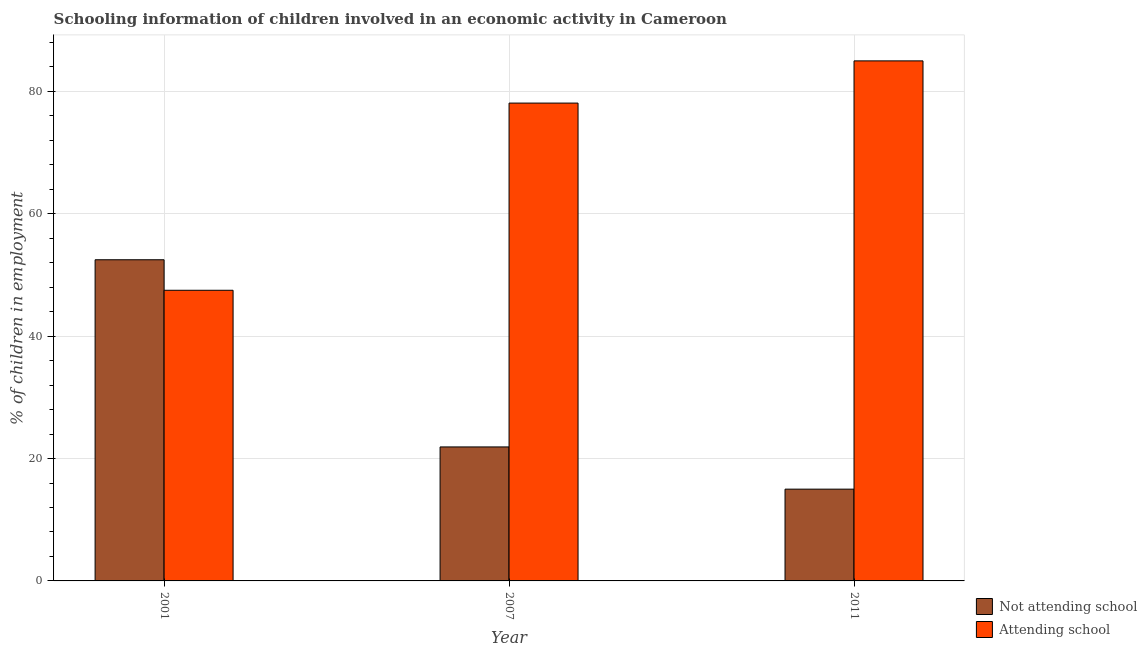How many different coloured bars are there?
Your answer should be very brief. 2. Are the number of bars on each tick of the X-axis equal?
Provide a short and direct response. Yes. How many bars are there on the 3rd tick from the right?
Keep it short and to the point. 2. What is the label of the 1st group of bars from the left?
Make the answer very short. 2001. In how many cases, is the number of bars for a given year not equal to the number of legend labels?
Offer a very short reply. 0. What is the percentage of employed children who are attending school in 2007?
Your response must be concise. 78.1. Across all years, what is the maximum percentage of employed children who are not attending school?
Ensure brevity in your answer.  52.49. Across all years, what is the minimum percentage of employed children who are not attending school?
Ensure brevity in your answer.  15. In which year was the percentage of employed children who are not attending school maximum?
Your answer should be compact. 2001. What is the total percentage of employed children who are not attending school in the graph?
Offer a terse response. 89.39. What is the difference between the percentage of employed children who are not attending school in 2007 and that in 2011?
Your answer should be compact. 6.9. What is the difference between the percentage of employed children who are attending school in 2001 and the percentage of employed children who are not attending school in 2007?
Your answer should be very brief. -30.59. What is the average percentage of employed children who are attending school per year?
Your answer should be compact. 70.2. In the year 2001, what is the difference between the percentage of employed children who are not attending school and percentage of employed children who are attending school?
Your answer should be compact. 0. What is the ratio of the percentage of employed children who are attending school in 2007 to that in 2011?
Your response must be concise. 0.92. What is the difference between the highest and the second highest percentage of employed children who are attending school?
Provide a succinct answer. 6.9. What is the difference between the highest and the lowest percentage of employed children who are not attending school?
Make the answer very short. 37.49. Is the sum of the percentage of employed children who are not attending school in 2001 and 2011 greater than the maximum percentage of employed children who are attending school across all years?
Offer a terse response. Yes. What does the 2nd bar from the left in 2011 represents?
Give a very brief answer. Attending school. What does the 1st bar from the right in 2007 represents?
Keep it short and to the point. Attending school. How many bars are there?
Provide a short and direct response. 6. Are all the bars in the graph horizontal?
Offer a very short reply. No. How are the legend labels stacked?
Your answer should be very brief. Vertical. What is the title of the graph?
Offer a very short reply. Schooling information of children involved in an economic activity in Cameroon. Does "Urban agglomerations" appear as one of the legend labels in the graph?
Ensure brevity in your answer.  No. What is the label or title of the X-axis?
Your answer should be compact. Year. What is the label or title of the Y-axis?
Offer a terse response. % of children in employment. What is the % of children in employment of Not attending school in 2001?
Make the answer very short. 52.49. What is the % of children in employment in Attending school in 2001?
Your answer should be compact. 47.51. What is the % of children in employment in Not attending school in 2007?
Your answer should be compact. 21.9. What is the % of children in employment of Attending school in 2007?
Offer a very short reply. 78.1. What is the % of children in employment of Not attending school in 2011?
Your response must be concise. 15. What is the % of children in employment of Attending school in 2011?
Keep it short and to the point. 85. Across all years, what is the maximum % of children in employment of Not attending school?
Offer a terse response. 52.49. Across all years, what is the minimum % of children in employment in Not attending school?
Your response must be concise. 15. Across all years, what is the minimum % of children in employment in Attending school?
Your answer should be very brief. 47.51. What is the total % of children in employment of Not attending school in the graph?
Provide a succinct answer. 89.39. What is the total % of children in employment in Attending school in the graph?
Make the answer very short. 210.61. What is the difference between the % of children in employment in Not attending school in 2001 and that in 2007?
Give a very brief answer. 30.59. What is the difference between the % of children in employment in Attending school in 2001 and that in 2007?
Ensure brevity in your answer.  -30.59. What is the difference between the % of children in employment of Not attending school in 2001 and that in 2011?
Provide a succinct answer. 37.49. What is the difference between the % of children in employment in Attending school in 2001 and that in 2011?
Ensure brevity in your answer.  -37.49. What is the difference between the % of children in employment in Attending school in 2007 and that in 2011?
Ensure brevity in your answer.  -6.9. What is the difference between the % of children in employment in Not attending school in 2001 and the % of children in employment in Attending school in 2007?
Provide a short and direct response. -25.61. What is the difference between the % of children in employment of Not attending school in 2001 and the % of children in employment of Attending school in 2011?
Provide a succinct answer. -32.51. What is the difference between the % of children in employment of Not attending school in 2007 and the % of children in employment of Attending school in 2011?
Provide a short and direct response. -63.1. What is the average % of children in employment in Not attending school per year?
Provide a succinct answer. 29.8. What is the average % of children in employment of Attending school per year?
Offer a very short reply. 70.2. In the year 2001, what is the difference between the % of children in employment in Not attending school and % of children in employment in Attending school?
Ensure brevity in your answer.  4.99. In the year 2007, what is the difference between the % of children in employment in Not attending school and % of children in employment in Attending school?
Provide a short and direct response. -56.2. In the year 2011, what is the difference between the % of children in employment in Not attending school and % of children in employment in Attending school?
Give a very brief answer. -70. What is the ratio of the % of children in employment in Not attending school in 2001 to that in 2007?
Offer a terse response. 2.4. What is the ratio of the % of children in employment in Attending school in 2001 to that in 2007?
Make the answer very short. 0.61. What is the ratio of the % of children in employment in Not attending school in 2001 to that in 2011?
Provide a succinct answer. 3.5. What is the ratio of the % of children in employment in Attending school in 2001 to that in 2011?
Make the answer very short. 0.56. What is the ratio of the % of children in employment of Not attending school in 2007 to that in 2011?
Give a very brief answer. 1.46. What is the ratio of the % of children in employment of Attending school in 2007 to that in 2011?
Your answer should be very brief. 0.92. What is the difference between the highest and the second highest % of children in employment in Not attending school?
Provide a short and direct response. 30.59. What is the difference between the highest and the second highest % of children in employment of Attending school?
Your answer should be compact. 6.9. What is the difference between the highest and the lowest % of children in employment in Not attending school?
Provide a succinct answer. 37.49. What is the difference between the highest and the lowest % of children in employment of Attending school?
Give a very brief answer. 37.49. 